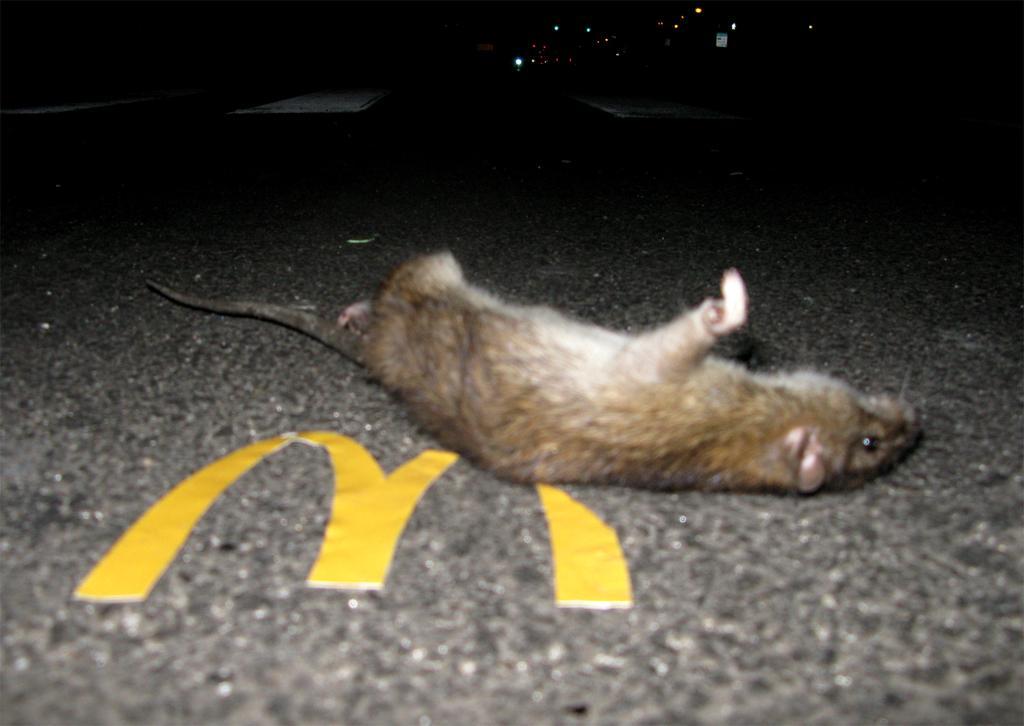Describe this image in one or two sentences. There is a rat on the road. Here we can see lights and there is a dark background. 